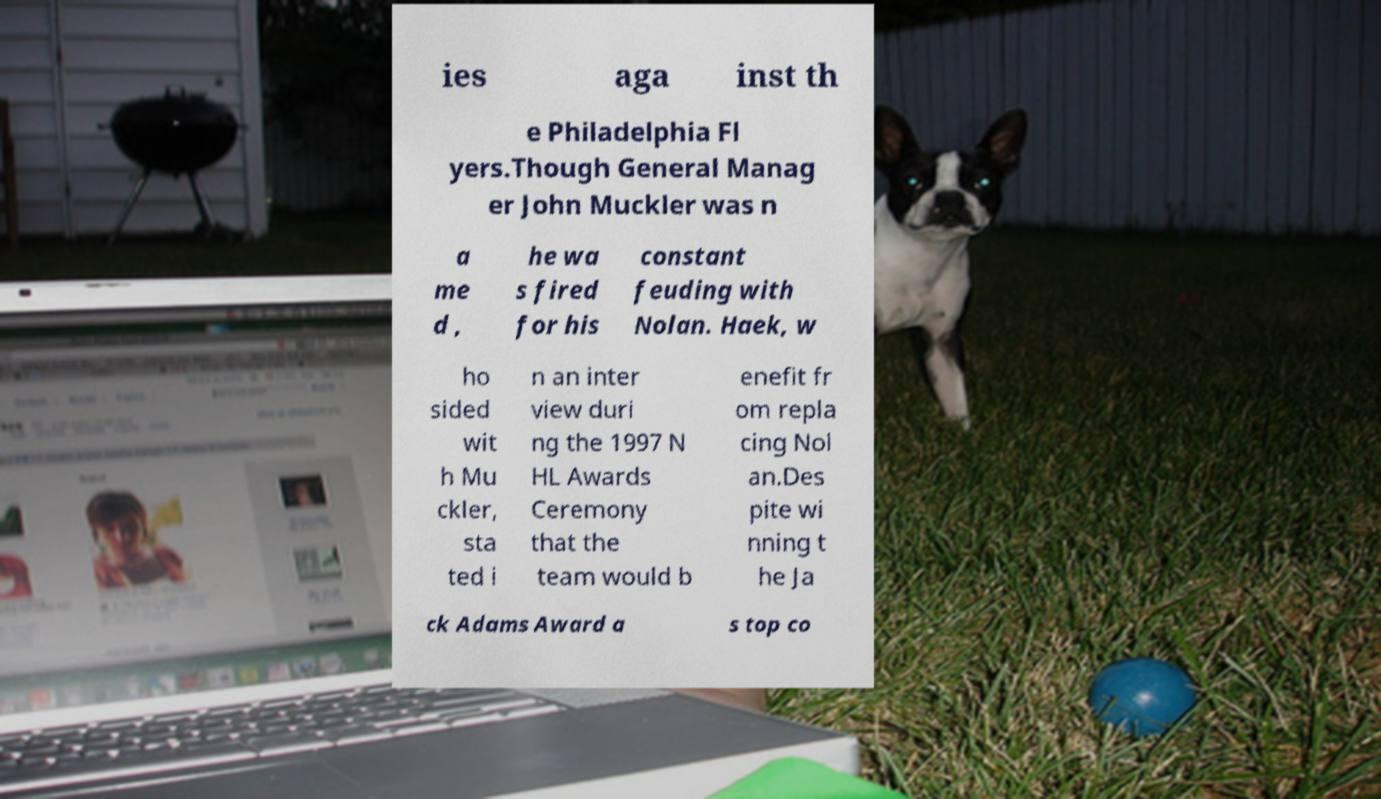For documentation purposes, I need the text within this image transcribed. Could you provide that? ies aga inst th e Philadelphia Fl yers.Though General Manag er John Muckler was n a me d , he wa s fired for his constant feuding with Nolan. Haek, w ho sided wit h Mu ckler, sta ted i n an inter view duri ng the 1997 N HL Awards Ceremony that the team would b enefit fr om repla cing Nol an.Des pite wi nning t he Ja ck Adams Award a s top co 